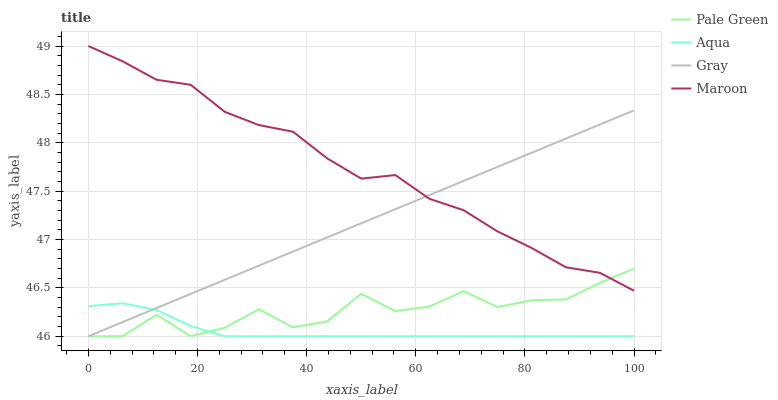Does Aqua have the minimum area under the curve?
Answer yes or no. Yes. Does Maroon have the maximum area under the curve?
Answer yes or no. Yes. Does Pale Green have the minimum area under the curve?
Answer yes or no. No. Does Pale Green have the maximum area under the curve?
Answer yes or no. No. Is Gray the smoothest?
Answer yes or no. Yes. Is Pale Green the roughest?
Answer yes or no. Yes. Is Aqua the smoothest?
Answer yes or no. No. Is Aqua the roughest?
Answer yes or no. No. Does Gray have the lowest value?
Answer yes or no. Yes. Does Maroon have the lowest value?
Answer yes or no. No. Does Maroon have the highest value?
Answer yes or no. Yes. Does Pale Green have the highest value?
Answer yes or no. No. Is Aqua less than Maroon?
Answer yes or no. Yes. Is Maroon greater than Aqua?
Answer yes or no. Yes. Does Maroon intersect Pale Green?
Answer yes or no. Yes. Is Maroon less than Pale Green?
Answer yes or no. No. Is Maroon greater than Pale Green?
Answer yes or no. No. Does Aqua intersect Maroon?
Answer yes or no. No. 